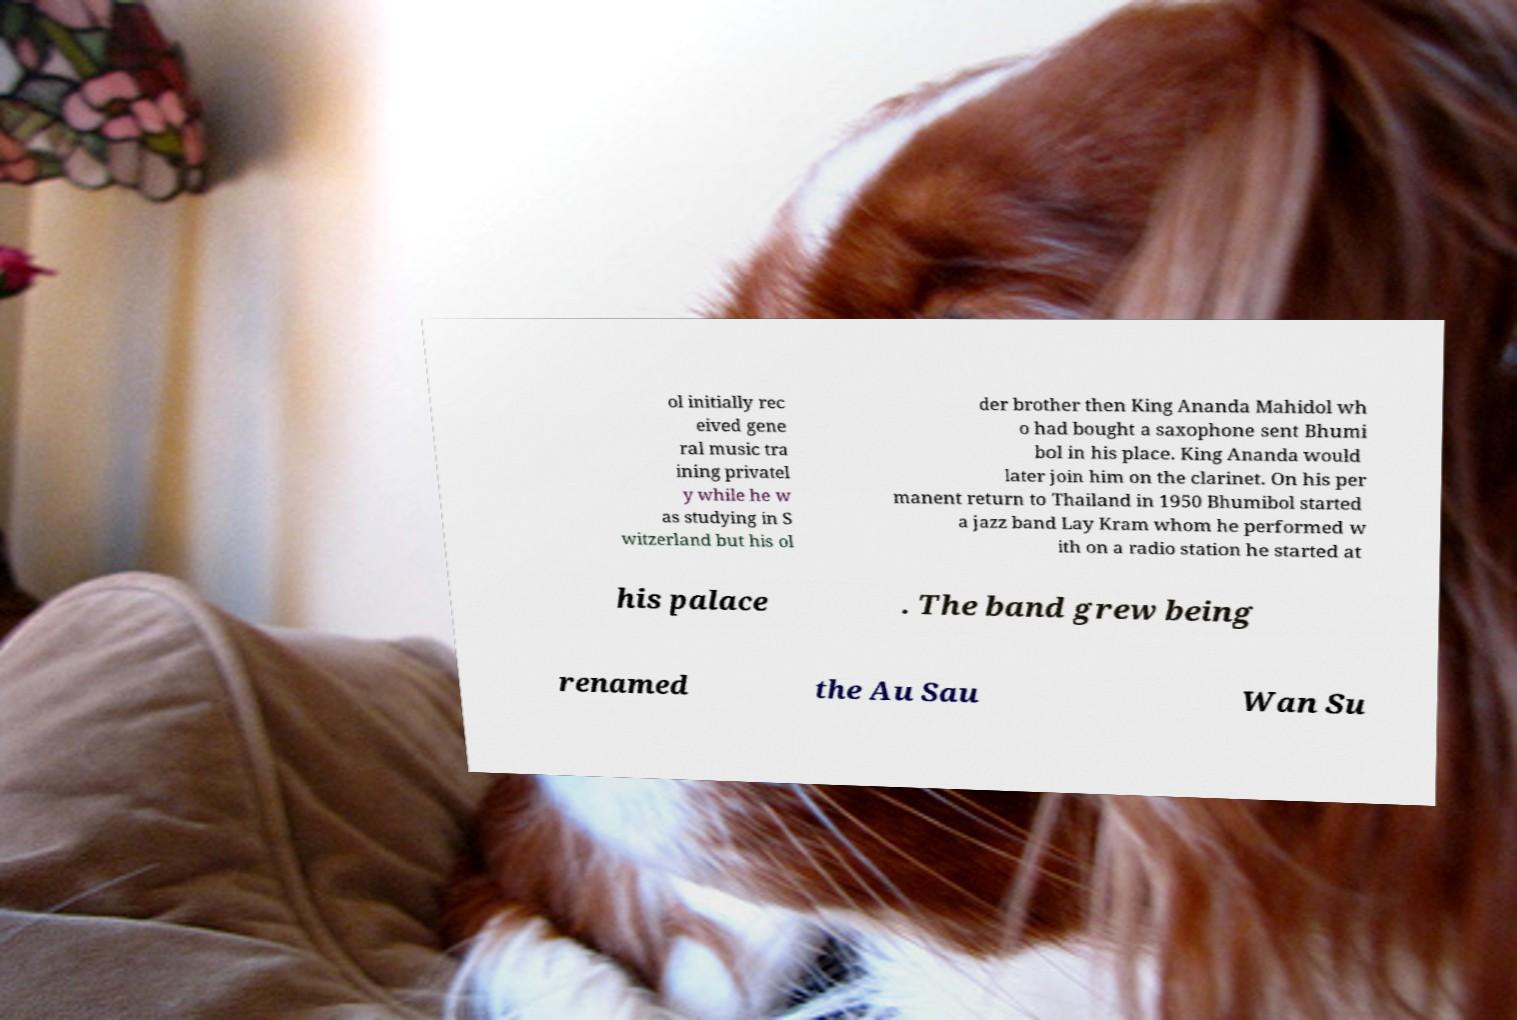Could you extract and type out the text from this image? ol initially rec eived gene ral music tra ining privatel y while he w as studying in S witzerland but his ol der brother then King Ananda Mahidol wh o had bought a saxophone sent Bhumi bol in his place. King Ananda would later join him on the clarinet. On his per manent return to Thailand in 1950 Bhumibol started a jazz band Lay Kram whom he performed w ith on a radio station he started at his palace . The band grew being renamed the Au Sau Wan Su 